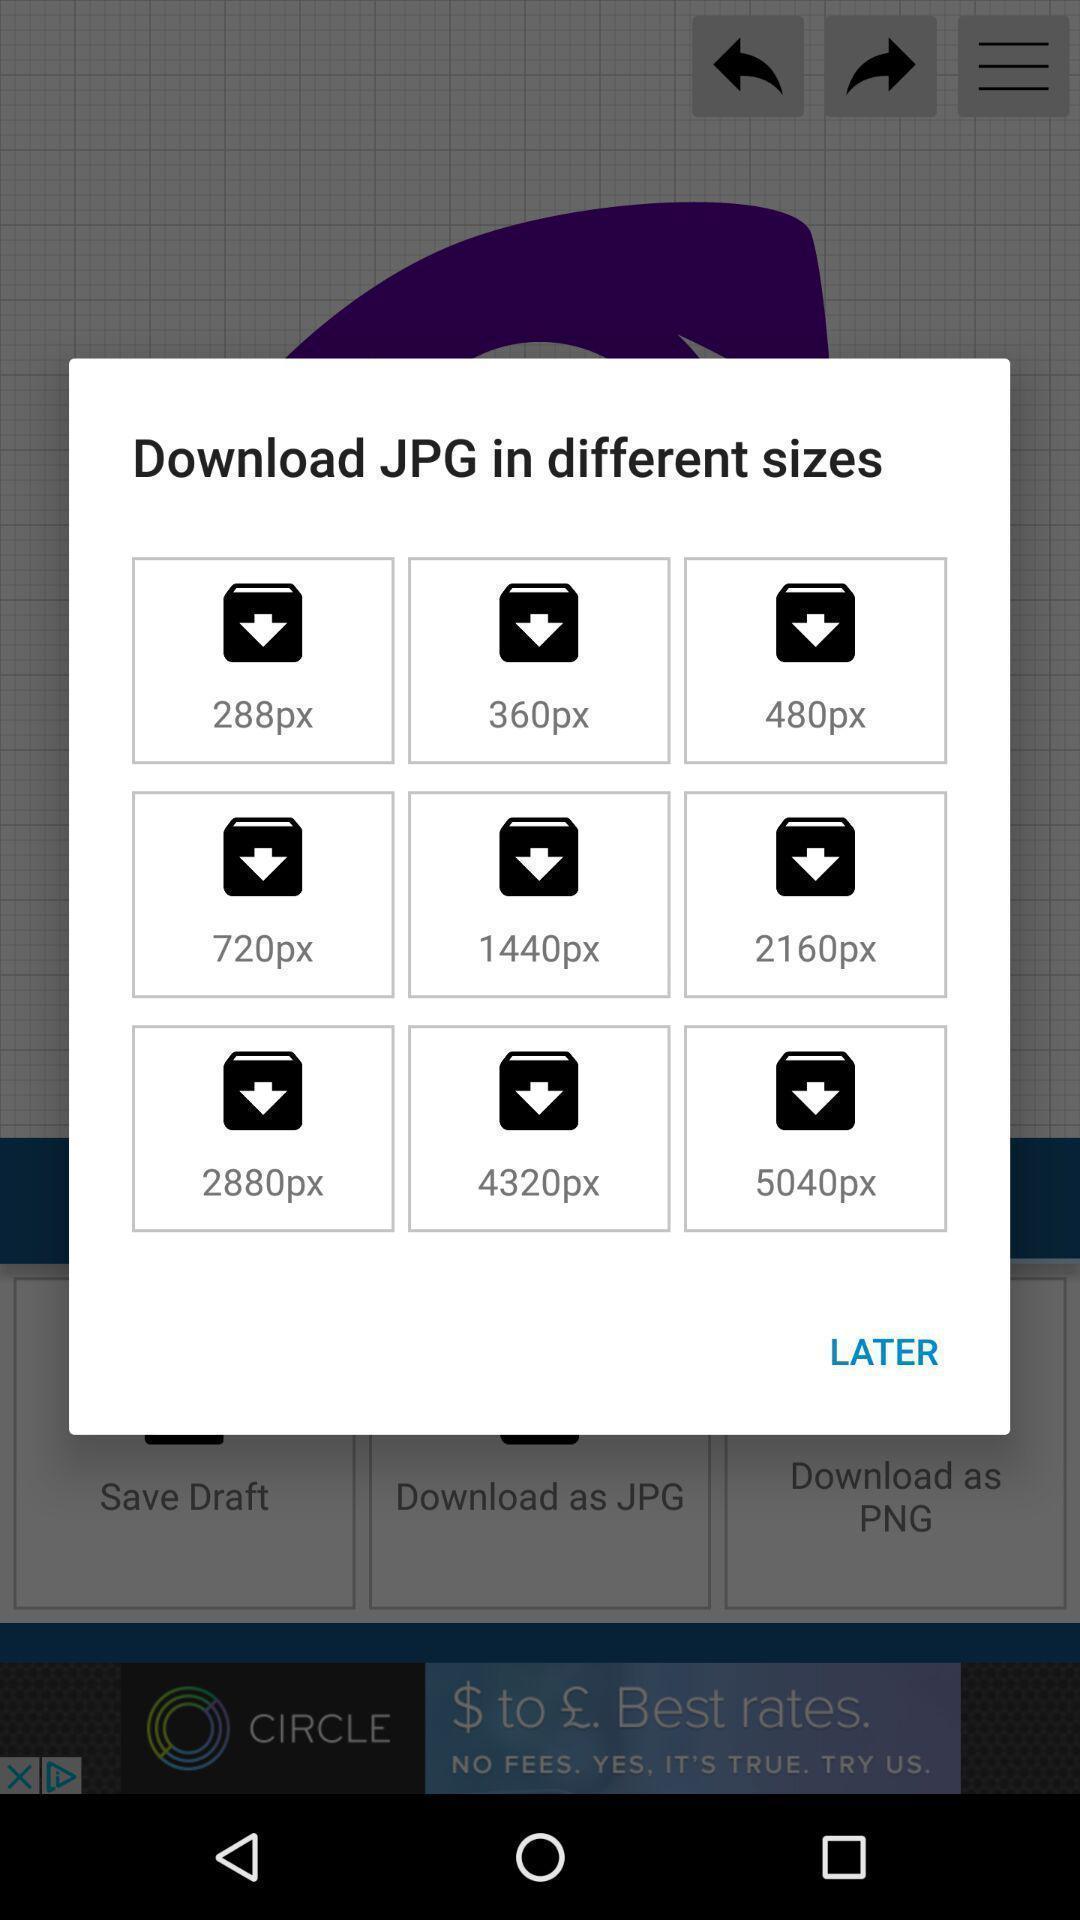What is the overall content of this screenshot? Pop-up for downloading jpg in different sizes. 